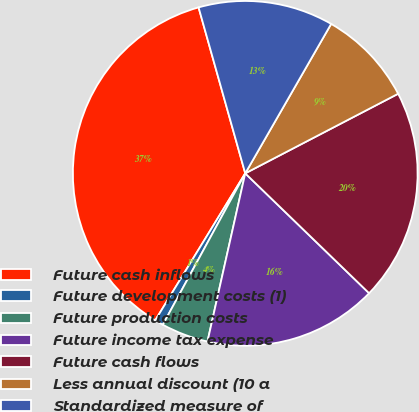Convert chart to OTSL. <chart><loc_0><loc_0><loc_500><loc_500><pie_chart><fcel>Future cash inflows<fcel>Future development costs (1)<fcel>Future production costs<fcel>Future income tax expense<fcel>Future cash flows<fcel>Less annual discount (10 a<fcel>Standardized measure of<nl><fcel>36.9%<fcel>0.81%<fcel>4.42%<fcel>16.28%<fcel>19.88%<fcel>9.06%<fcel>12.67%<nl></chart> 